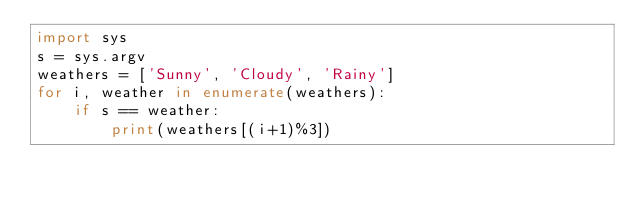Convert code to text. <code><loc_0><loc_0><loc_500><loc_500><_Python_>import sys
s = sys.argv
weathers = ['Sunny', 'Cloudy', 'Rainy']
for i, weather in enumerate(weathers):
    if s == weather:
        print(weathers[(i+1)%3])</code> 